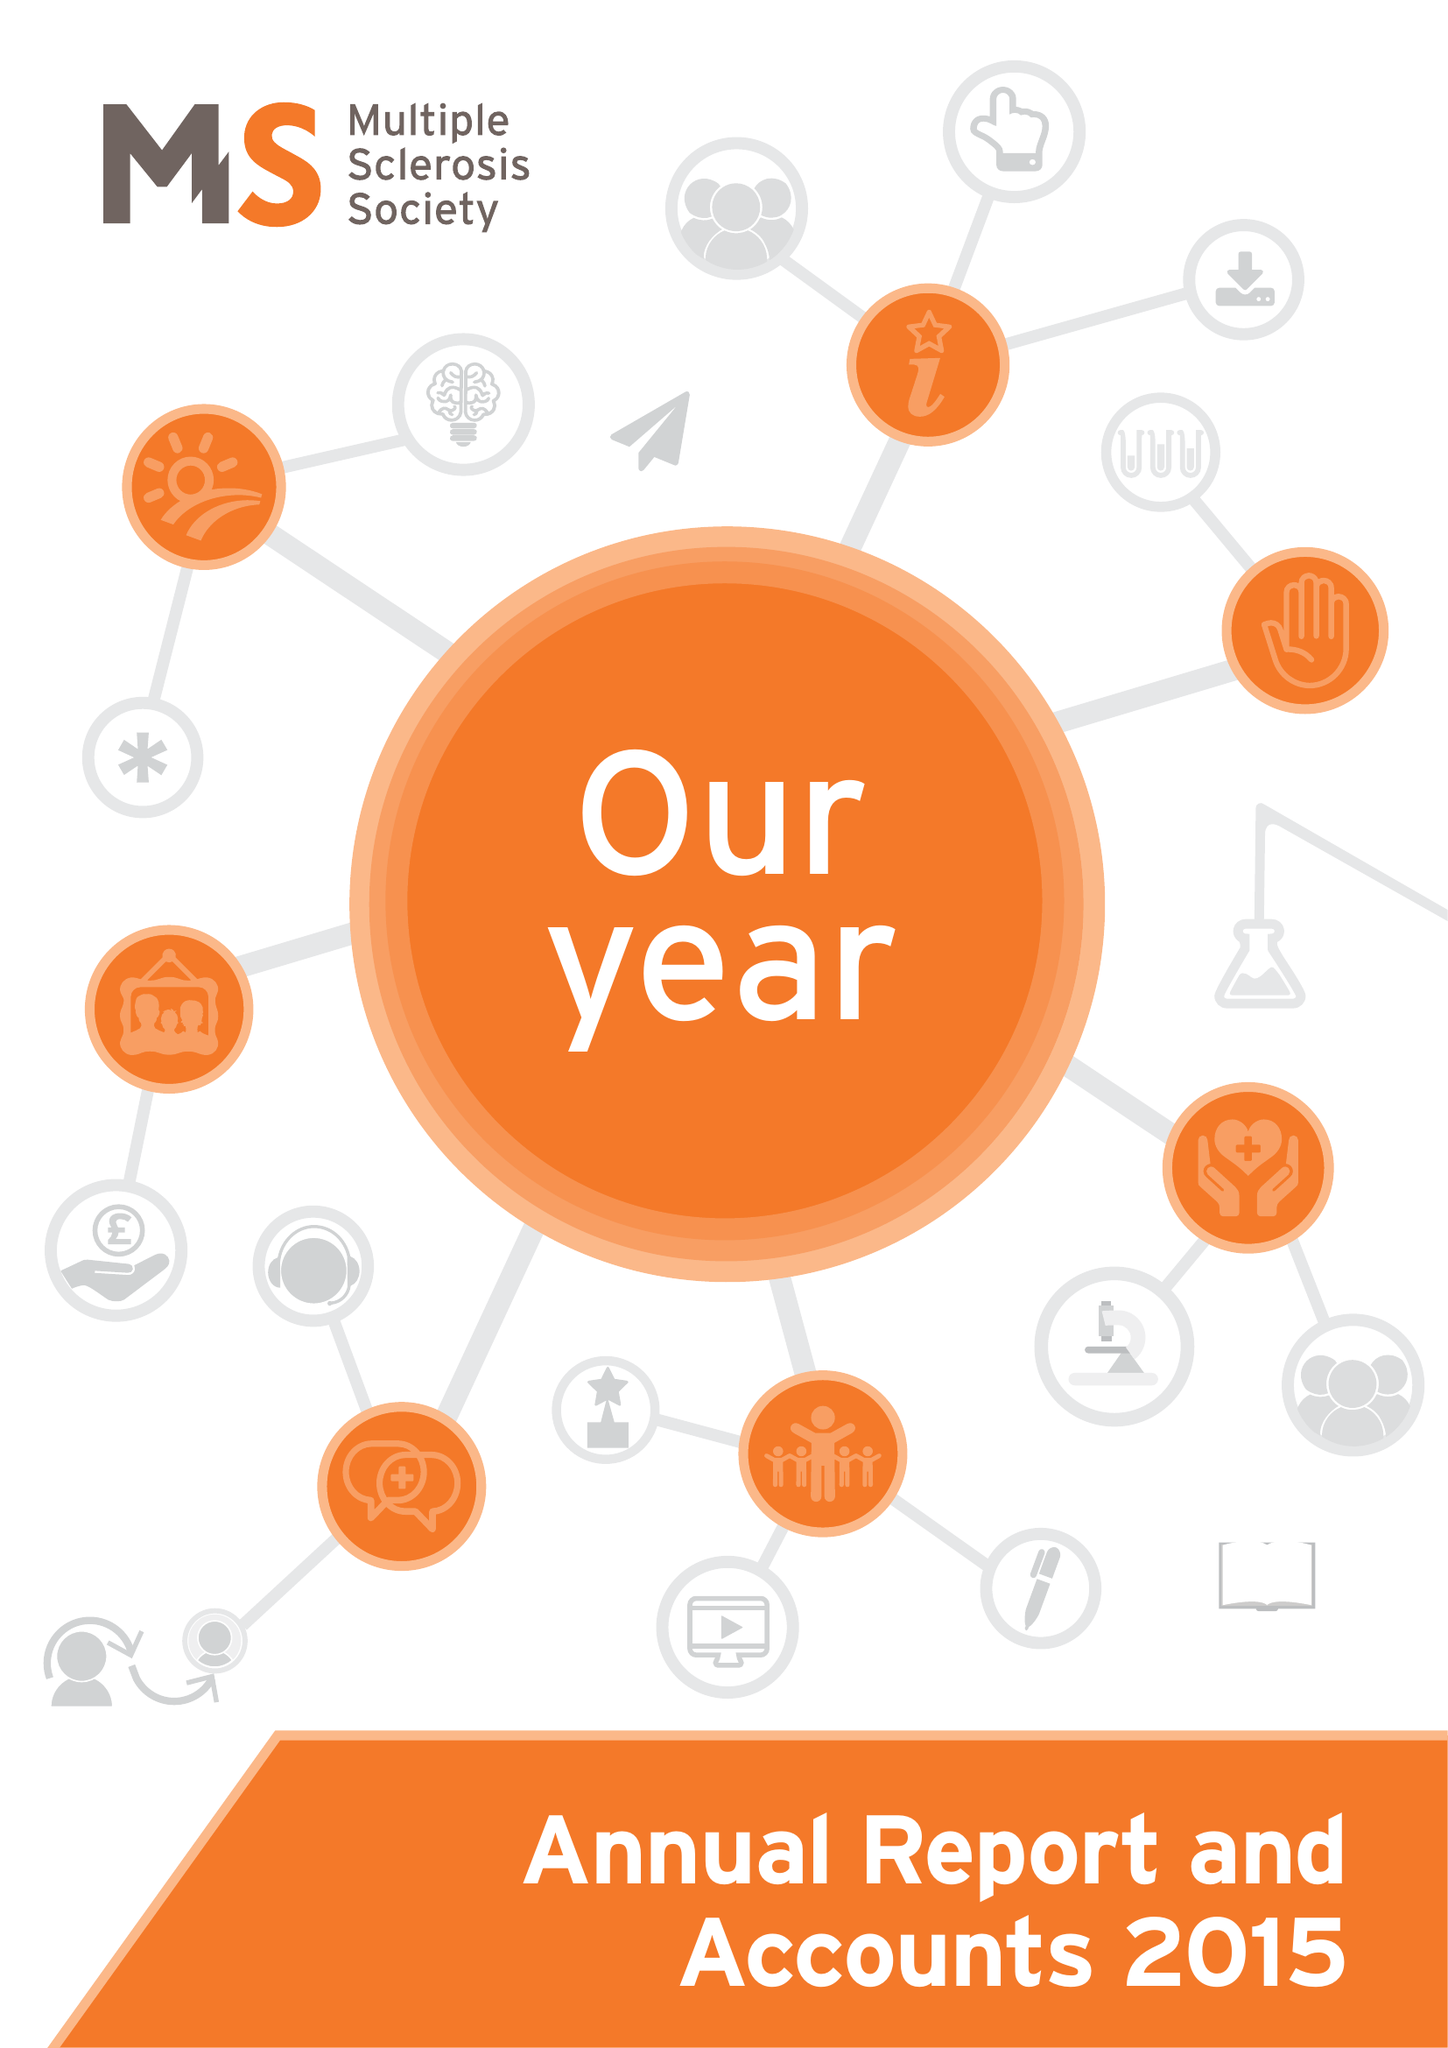What is the value for the charity_name?
Answer the question using a single word or phrase. Multiple Sclerosis Society 